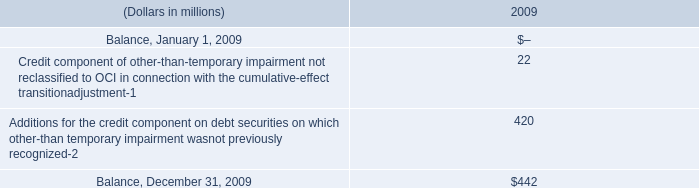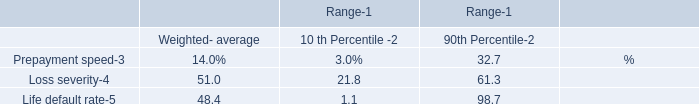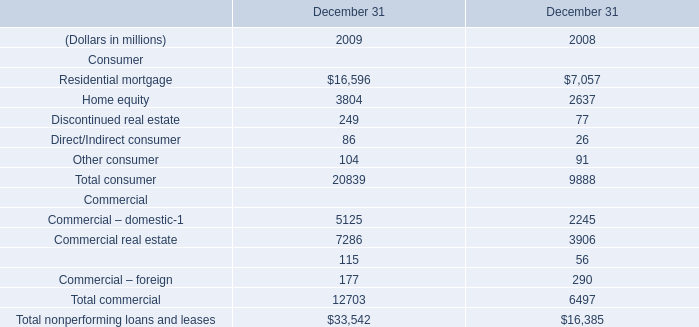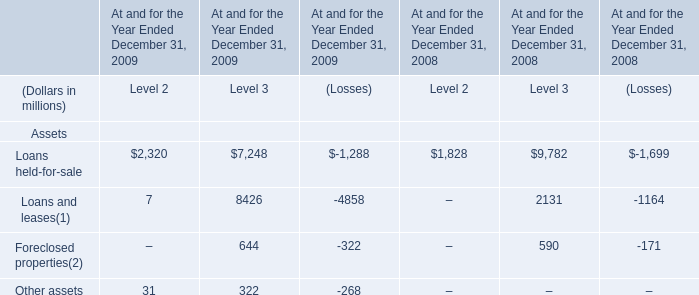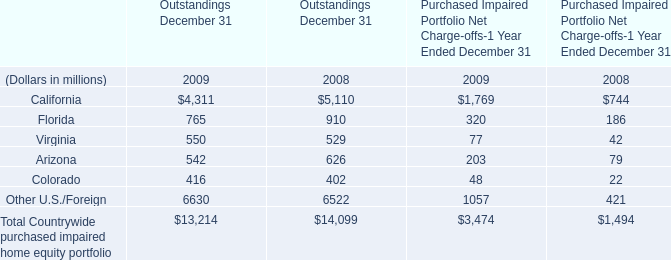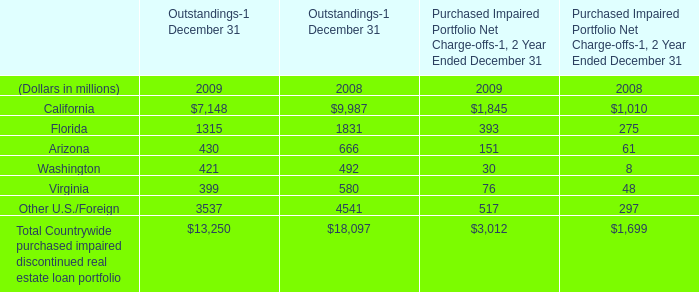What is the proportion of Florida of outstandings to the total in 2009? 
Computations: (1315 / 13250)
Answer: 0.09925. 